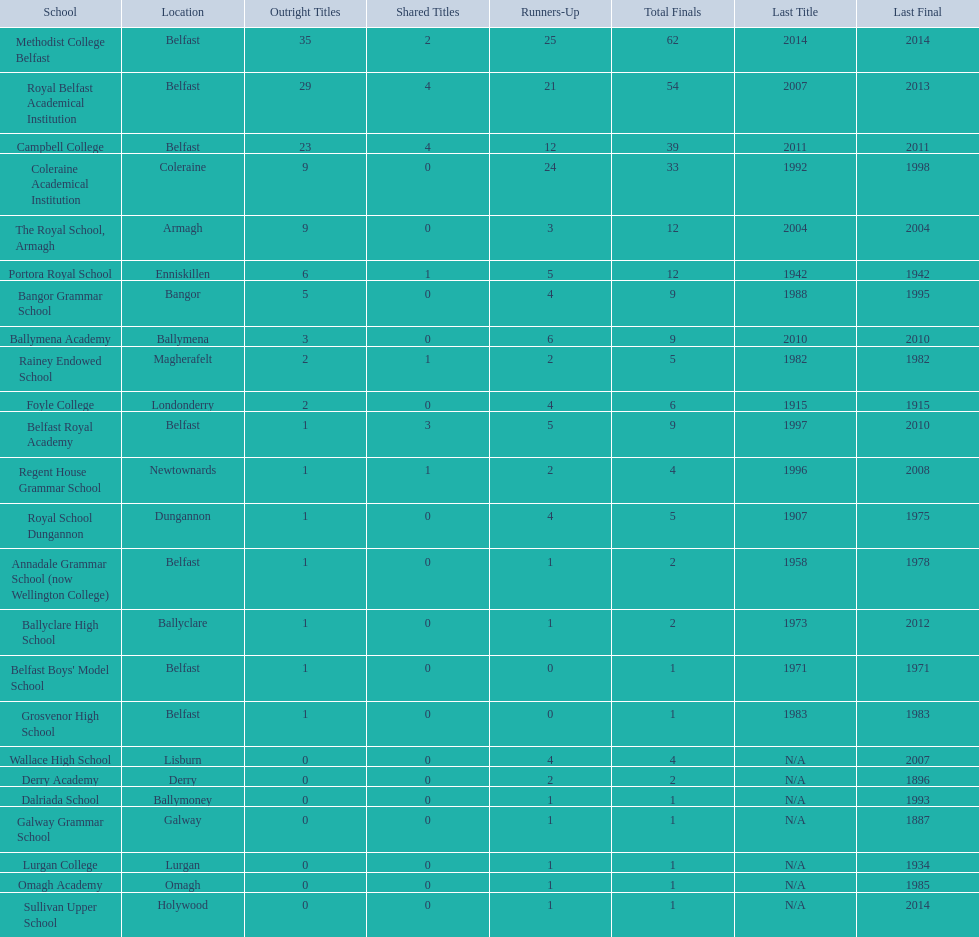What is the newest triumph of campbell college? 2011. What is the newest triumph of regent house grammar school? 1996. Which date is more up-to-date? 2011. What is the name of the school with this date? Campbell College. 